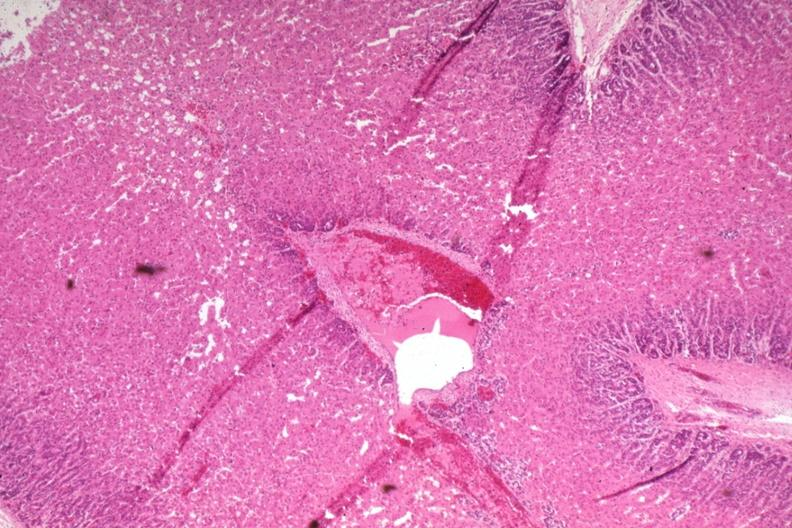what is present?
Answer the question using a single word or phrase. Adrenal 